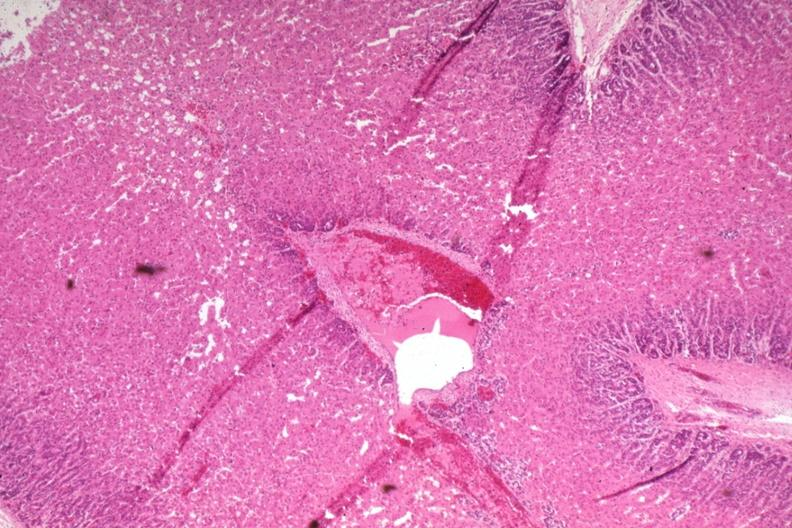what is present?
Answer the question using a single word or phrase. Adrenal 